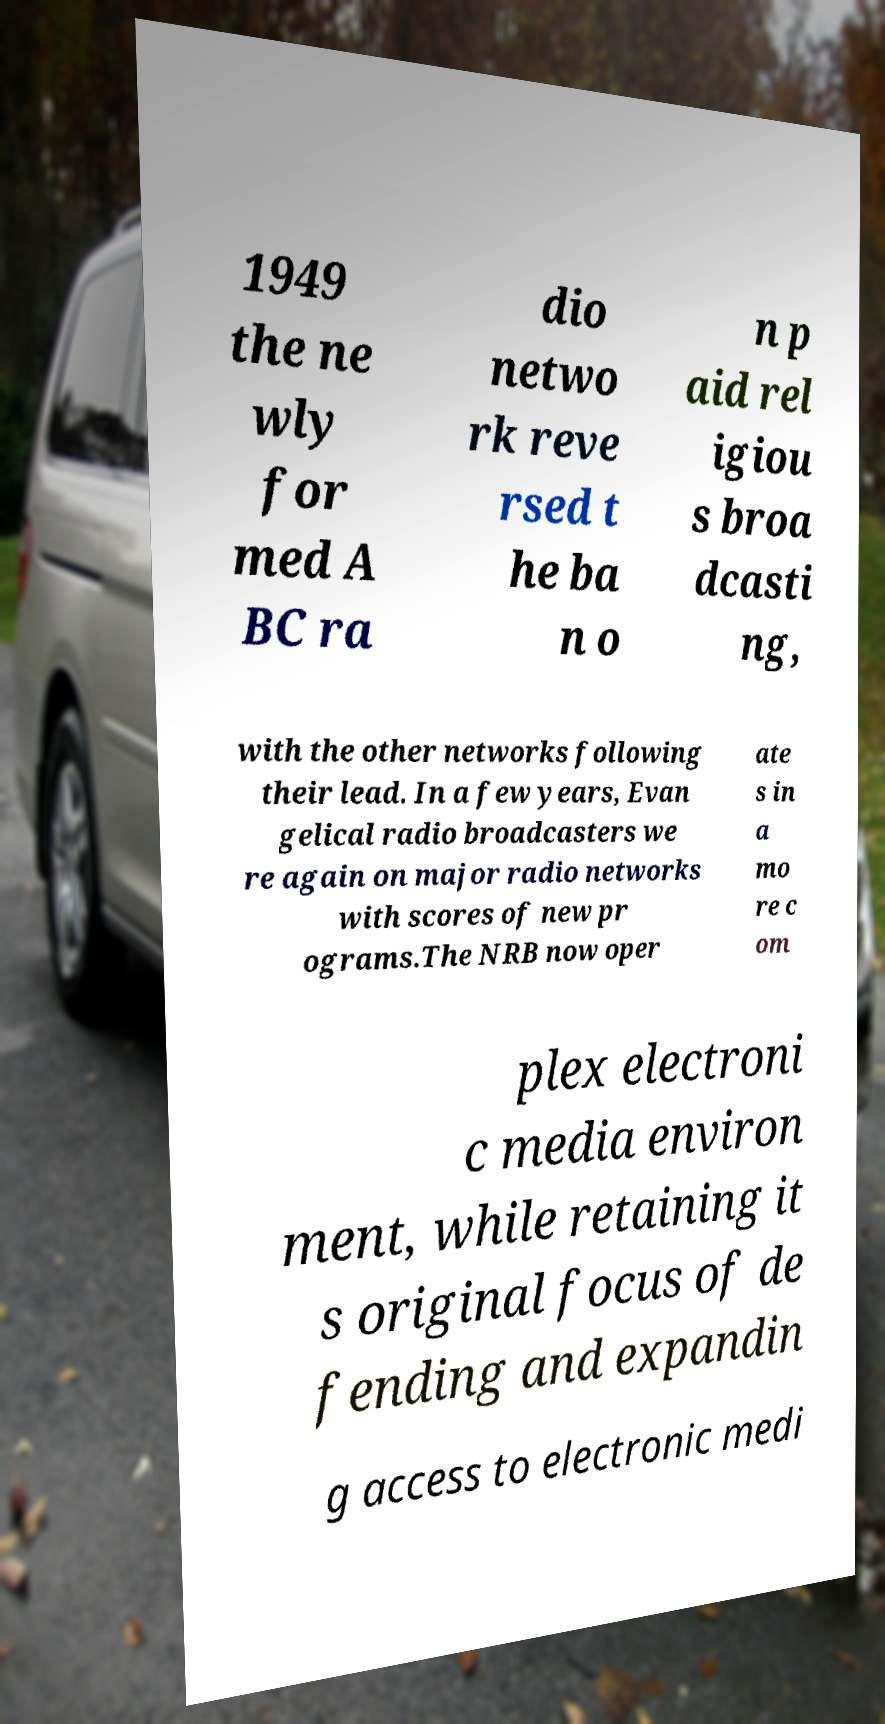What messages or text are displayed in this image? I need them in a readable, typed format. 1949 the ne wly for med A BC ra dio netwo rk reve rsed t he ba n o n p aid rel igiou s broa dcasti ng, with the other networks following their lead. In a few years, Evan gelical radio broadcasters we re again on major radio networks with scores of new pr ograms.The NRB now oper ate s in a mo re c om plex electroni c media environ ment, while retaining it s original focus of de fending and expandin g access to electronic medi 